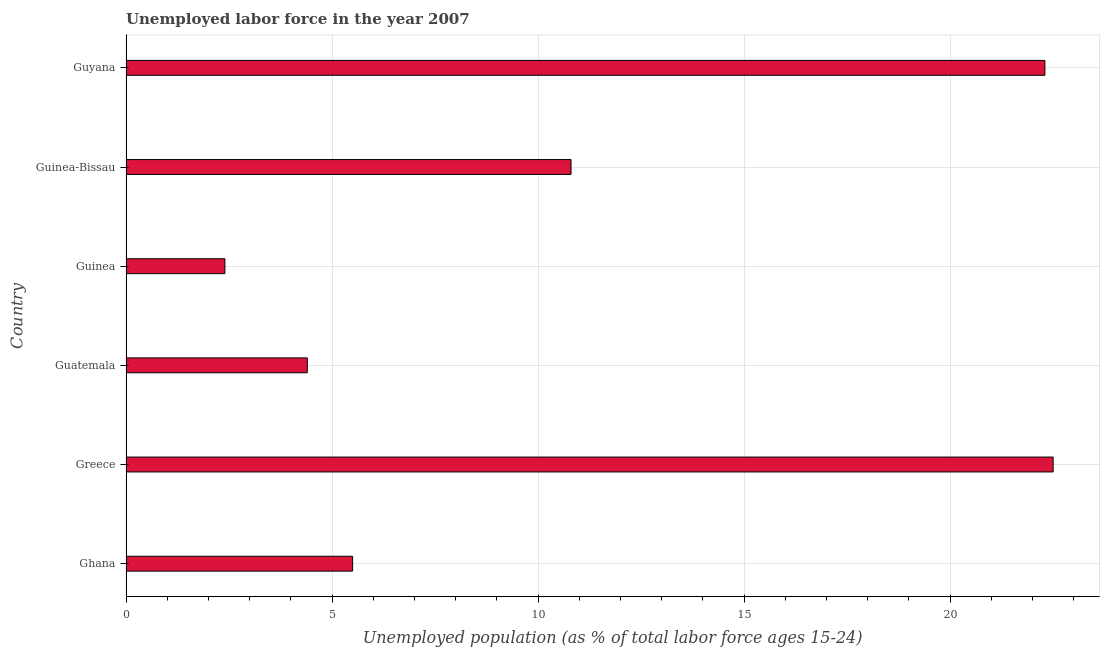Does the graph contain any zero values?
Offer a terse response. No. Does the graph contain grids?
Give a very brief answer. Yes. What is the title of the graph?
Offer a terse response. Unemployed labor force in the year 2007. What is the label or title of the X-axis?
Your response must be concise. Unemployed population (as % of total labor force ages 15-24). What is the label or title of the Y-axis?
Provide a succinct answer. Country. What is the total unemployed youth population in Guinea?
Provide a succinct answer. 2.4. Across all countries, what is the maximum total unemployed youth population?
Make the answer very short. 22.5. Across all countries, what is the minimum total unemployed youth population?
Ensure brevity in your answer.  2.4. In which country was the total unemployed youth population minimum?
Make the answer very short. Guinea. What is the sum of the total unemployed youth population?
Your answer should be compact. 67.9. What is the difference between the total unemployed youth population in Greece and Guatemala?
Provide a short and direct response. 18.1. What is the average total unemployed youth population per country?
Provide a succinct answer. 11.32. What is the median total unemployed youth population?
Ensure brevity in your answer.  8.15. In how many countries, is the total unemployed youth population greater than 1 %?
Provide a succinct answer. 6. Is the total unemployed youth population in Ghana less than that in Guinea?
Provide a succinct answer. No. What is the difference between the highest and the lowest total unemployed youth population?
Give a very brief answer. 20.1. How many bars are there?
Provide a succinct answer. 6. Are all the bars in the graph horizontal?
Give a very brief answer. Yes. What is the difference between two consecutive major ticks on the X-axis?
Provide a short and direct response. 5. Are the values on the major ticks of X-axis written in scientific E-notation?
Provide a succinct answer. No. What is the Unemployed population (as % of total labor force ages 15-24) in Guatemala?
Provide a succinct answer. 4.4. What is the Unemployed population (as % of total labor force ages 15-24) of Guinea?
Provide a succinct answer. 2.4. What is the Unemployed population (as % of total labor force ages 15-24) of Guinea-Bissau?
Ensure brevity in your answer.  10.8. What is the Unemployed population (as % of total labor force ages 15-24) of Guyana?
Provide a short and direct response. 22.3. What is the difference between the Unemployed population (as % of total labor force ages 15-24) in Ghana and Greece?
Keep it short and to the point. -17. What is the difference between the Unemployed population (as % of total labor force ages 15-24) in Ghana and Guinea?
Offer a very short reply. 3.1. What is the difference between the Unemployed population (as % of total labor force ages 15-24) in Ghana and Guyana?
Make the answer very short. -16.8. What is the difference between the Unemployed population (as % of total labor force ages 15-24) in Greece and Guinea?
Ensure brevity in your answer.  20.1. What is the difference between the Unemployed population (as % of total labor force ages 15-24) in Guatemala and Guyana?
Offer a very short reply. -17.9. What is the difference between the Unemployed population (as % of total labor force ages 15-24) in Guinea and Guyana?
Provide a short and direct response. -19.9. What is the ratio of the Unemployed population (as % of total labor force ages 15-24) in Ghana to that in Greece?
Make the answer very short. 0.24. What is the ratio of the Unemployed population (as % of total labor force ages 15-24) in Ghana to that in Guinea?
Provide a short and direct response. 2.29. What is the ratio of the Unemployed population (as % of total labor force ages 15-24) in Ghana to that in Guinea-Bissau?
Your response must be concise. 0.51. What is the ratio of the Unemployed population (as % of total labor force ages 15-24) in Ghana to that in Guyana?
Your answer should be compact. 0.25. What is the ratio of the Unemployed population (as % of total labor force ages 15-24) in Greece to that in Guatemala?
Ensure brevity in your answer.  5.11. What is the ratio of the Unemployed population (as % of total labor force ages 15-24) in Greece to that in Guinea?
Ensure brevity in your answer.  9.38. What is the ratio of the Unemployed population (as % of total labor force ages 15-24) in Greece to that in Guinea-Bissau?
Your answer should be very brief. 2.08. What is the ratio of the Unemployed population (as % of total labor force ages 15-24) in Guatemala to that in Guinea?
Your response must be concise. 1.83. What is the ratio of the Unemployed population (as % of total labor force ages 15-24) in Guatemala to that in Guinea-Bissau?
Give a very brief answer. 0.41. What is the ratio of the Unemployed population (as % of total labor force ages 15-24) in Guatemala to that in Guyana?
Keep it short and to the point. 0.2. What is the ratio of the Unemployed population (as % of total labor force ages 15-24) in Guinea to that in Guinea-Bissau?
Keep it short and to the point. 0.22. What is the ratio of the Unemployed population (as % of total labor force ages 15-24) in Guinea to that in Guyana?
Keep it short and to the point. 0.11. What is the ratio of the Unemployed population (as % of total labor force ages 15-24) in Guinea-Bissau to that in Guyana?
Your response must be concise. 0.48. 